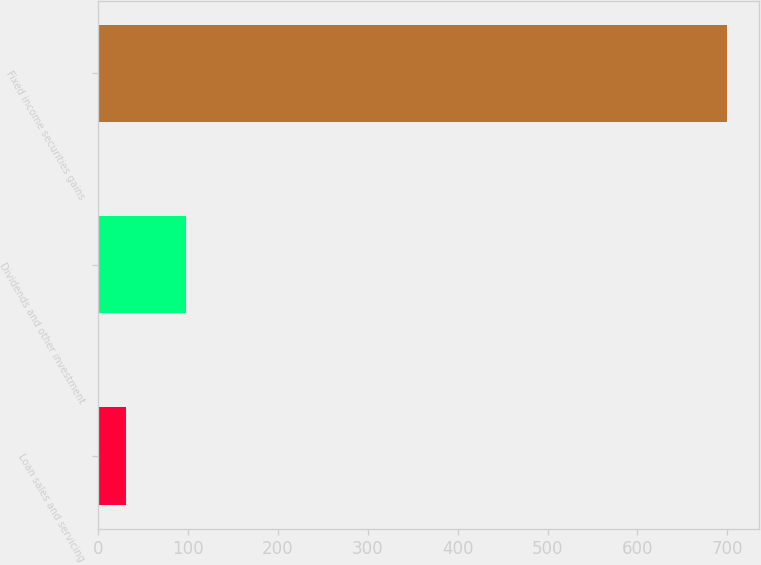Convert chart to OTSL. <chart><loc_0><loc_0><loc_500><loc_500><bar_chart><fcel>Loan sales and servicing<fcel>Dividends and other investment<fcel>Fixed income securities gains<nl><fcel>30.3<fcel>97.27<fcel>700<nl></chart> 